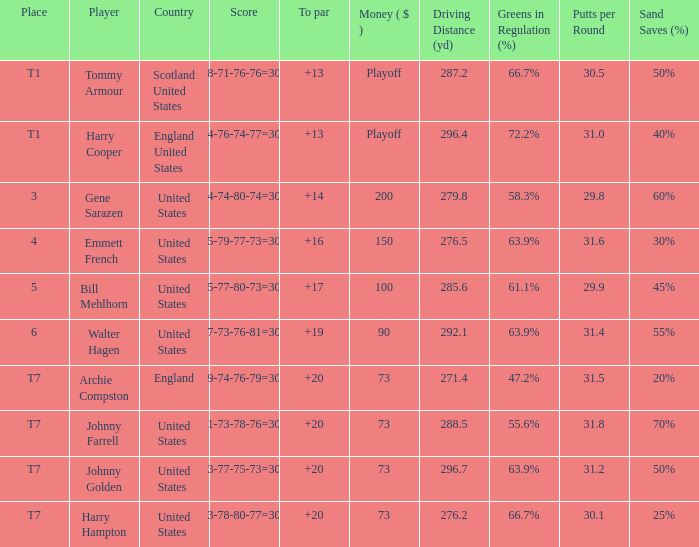What is the ranking for the United States when the money is $200? 3.0. 